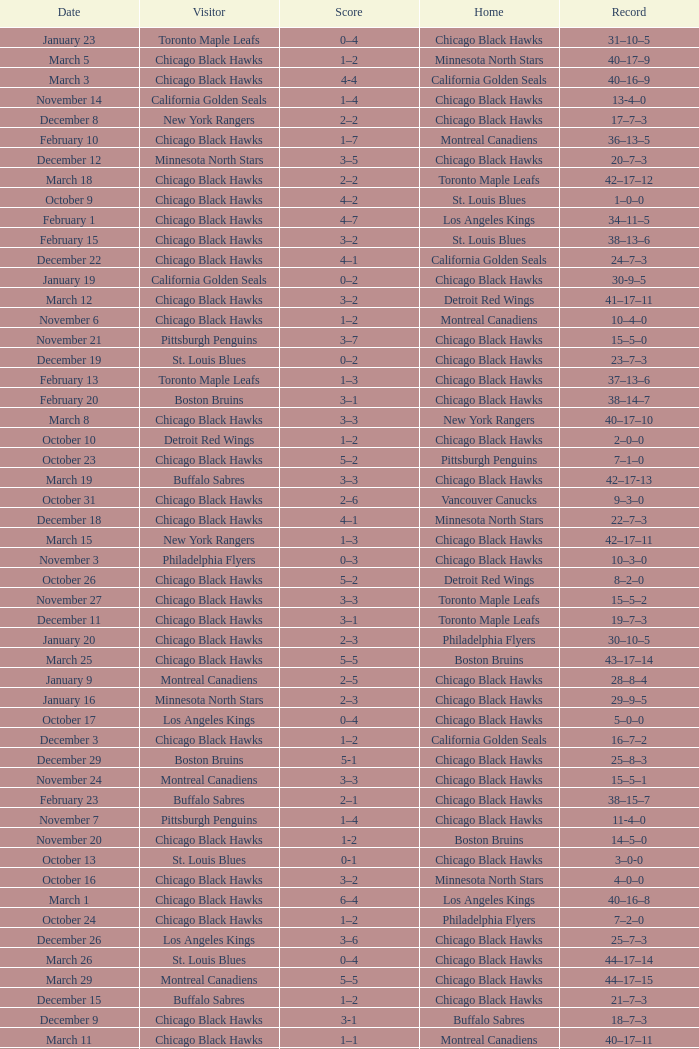What is the Score of the Chicago Black Hawks Home game with the Visiting Vancouver Canucks on November 17? 0-3. 